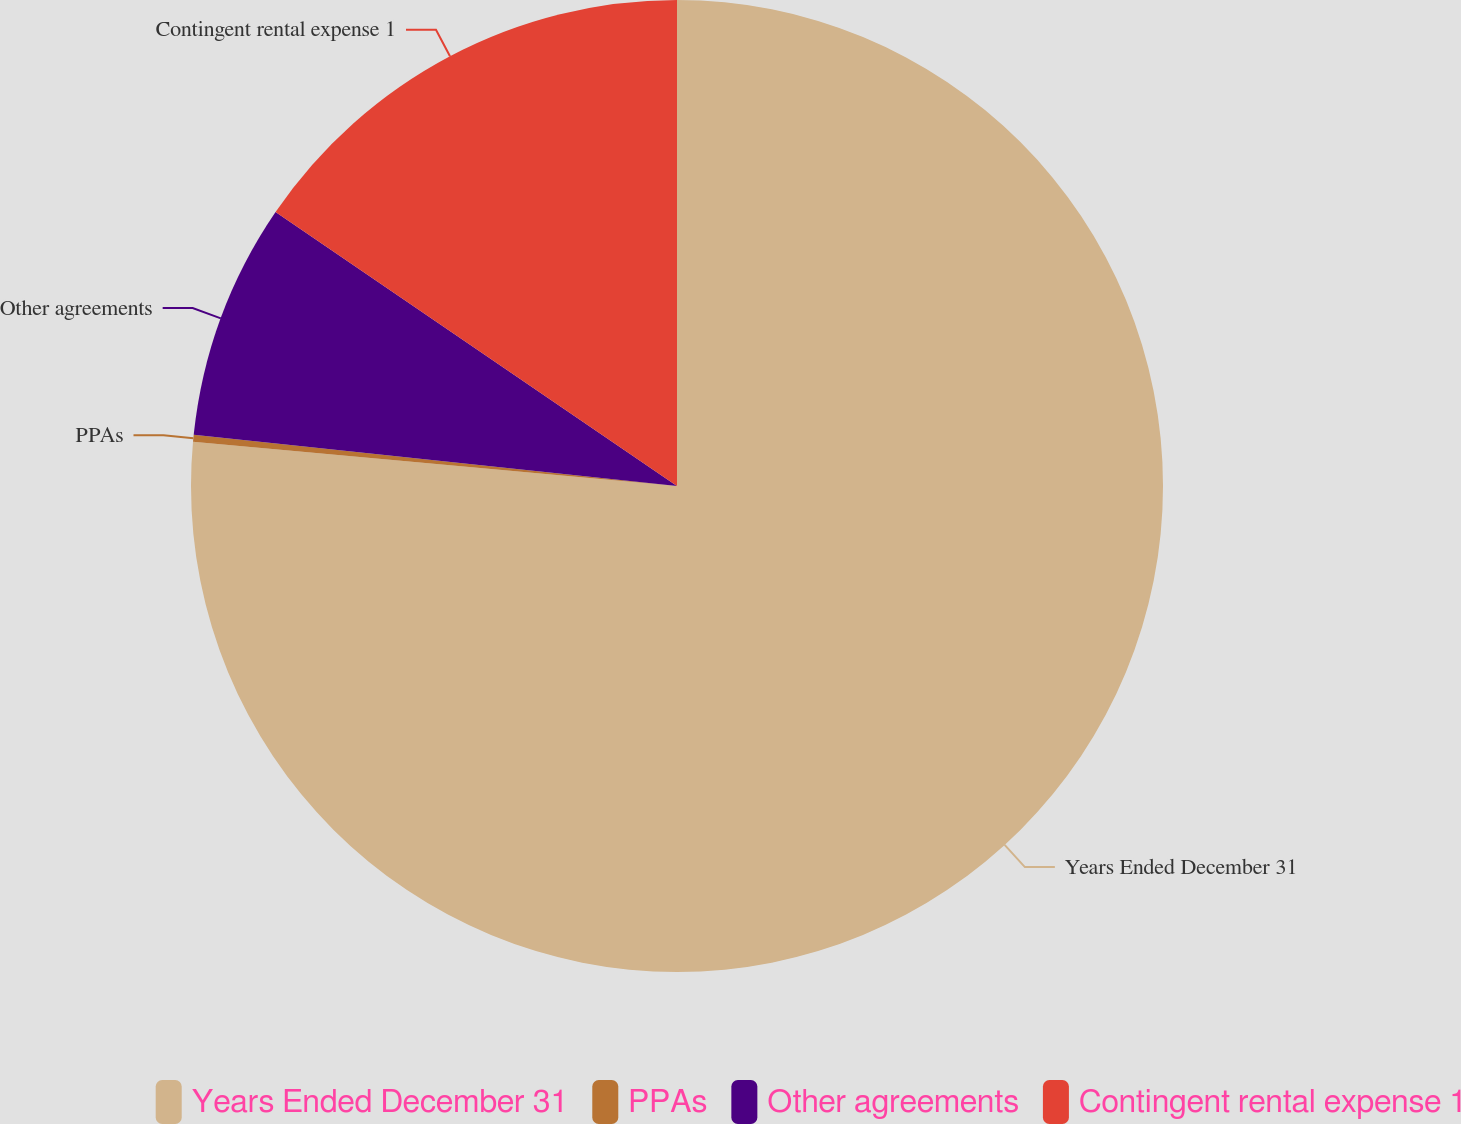Convert chart. <chart><loc_0><loc_0><loc_500><loc_500><pie_chart><fcel>Years Ended December 31<fcel>PPAs<fcel>Other agreements<fcel>Contingent rental expense 1<nl><fcel>76.45%<fcel>0.23%<fcel>7.85%<fcel>15.47%<nl></chart> 